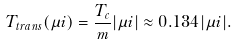Convert formula to latex. <formula><loc_0><loc_0><loc_500><loc_500>T _ { t r a n s } ( \mu i ) = \frac { T _ { c } } { m } | \mu i | \approx 0 . 1 3 4 | \mu i | .</formula> 